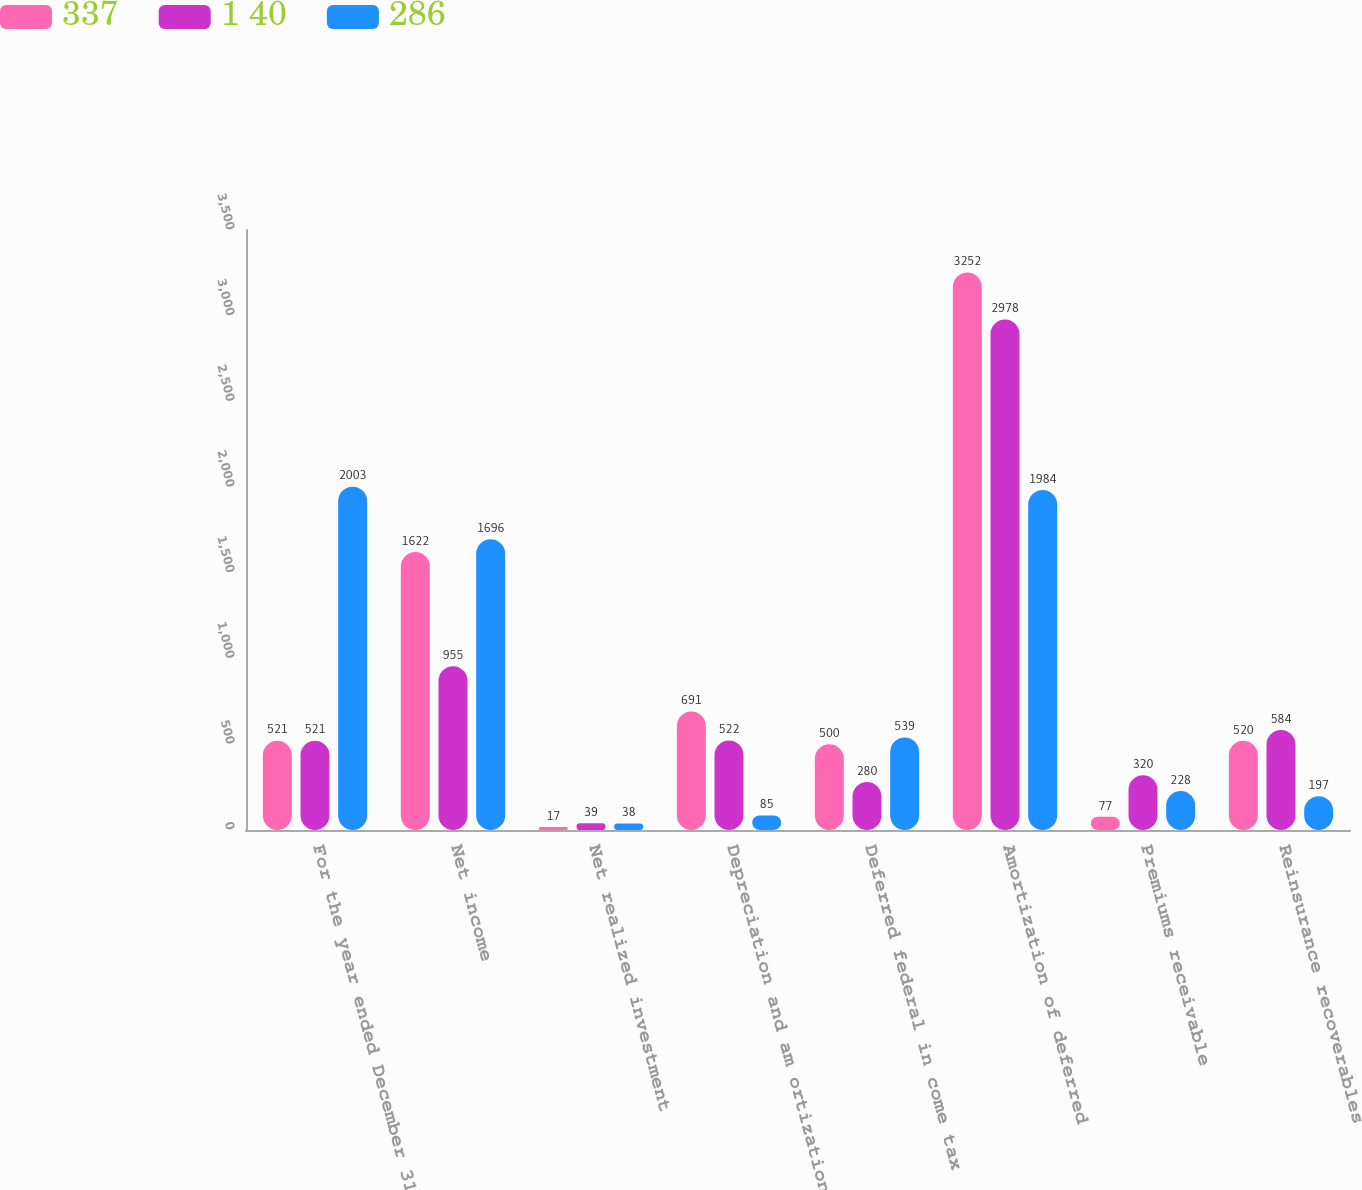<chart> <loc_0><loc_0><loc_500><loc_500><stacked_bar_chart><ecel><fcel>For the year ended December 31<fcel>Net income<fcel>Net realized investment<fcel>Depreciation and am ortization<fcel>Deferred federal in come tax<fcel>Amortization of deferred<fcel>Premiums receivable<fcel>Reinsurance recoverables<nl><fcel>337<fcel>521<fcel>1622<fcel>17<fcel>691<fcel>500<fcel>3252<fcel>77<fcel>520<nl><fcel>1 40<fcel>521<fcel>955<fcel>39<fcel>522<fcel>280<fcel>2978<fcel>320<fcel>584<nl><fcel>286<fcel>2003<fcel>1696<fcel>38<fcel>85<fcel>539<fcel>1984<fcel>228<fcel>197<nl></chart> 